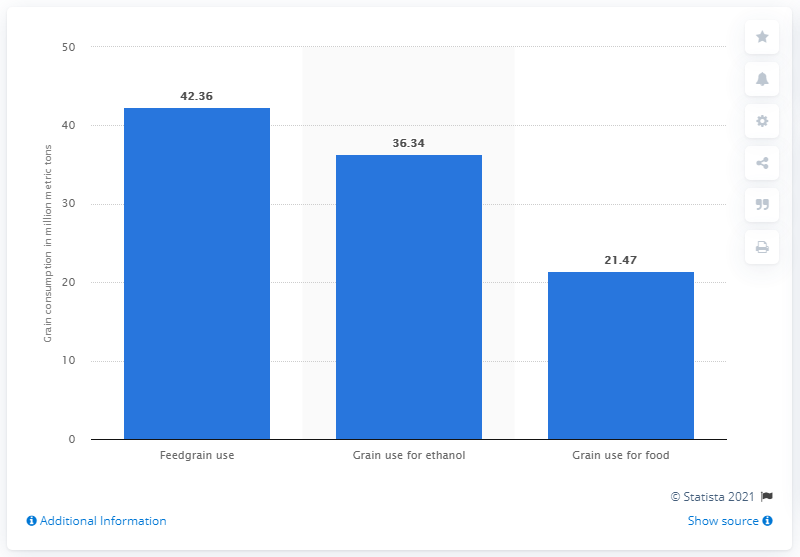Outline some significant characteristics in this image. In 2013, a total of 36.34% of grains were used for the production of ethanol. 